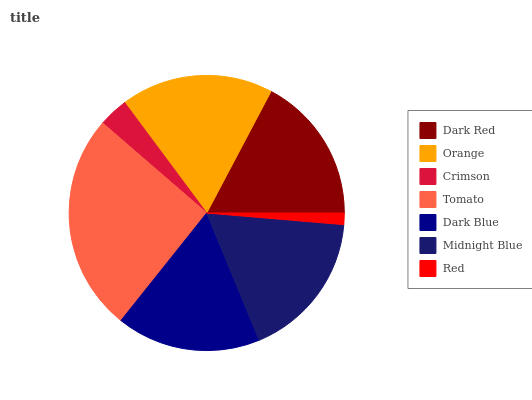Is Red the minimum?
Answer yes or no. Yes. Is Tomato the maximum?
Answer yes or no. Yes. Is Orange the minimum?
Answer yes or no. No. Is Orange the maximum?
Answer yes or no. No. Is Orange greater than Dark Red?
Answer yes or no. Yes. Is Dark Red less than Orange?
Answer yes or no. Yes. Is Dark Red greater than Orange?
Answer yes or no. No. Is Orange less than Dark Red?
Answer yes or no. No. Is Dark Red the high median?
Answer yes or no. Yes. Is Dark Red the low median?
Answer yes or no. Yes. Is Tomato the high median?
Answer yes or no. No. Is Tomato the low median?
Answer yes or no. No. 